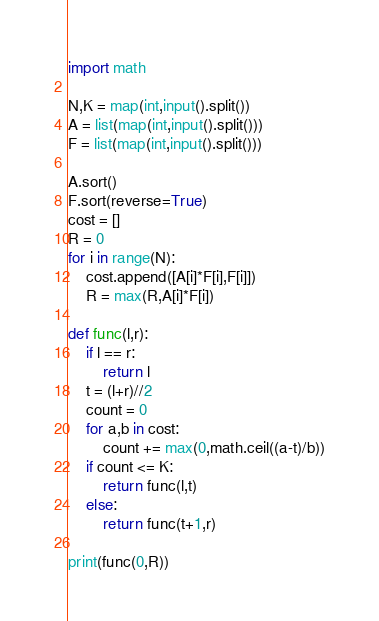Convert code to text. <code><loc_0><loc_0><loc_500><loc_500><_Python_>import math

N,K = map(int,input().split())
A = list(map(int,input().split()))
F = list(map(int,input().split()))

A.sort()
F.sort(reverse=True)
cost = []
R = 0
for i in range(N):
    cost.append([A[i]*F[i],F[i]])
    R = max(R,A[i]*F[i])

def func(l,r):
    if l == r:
        return l
    t = (l+r)//2
    count = 0
    for a,b in cost:
        count += max(0,math.ceil((a-t)/b))
    if count <= K:
        return func(l,t)
    else:
        return func(t+1,r)

print(func(0,R))</code> 